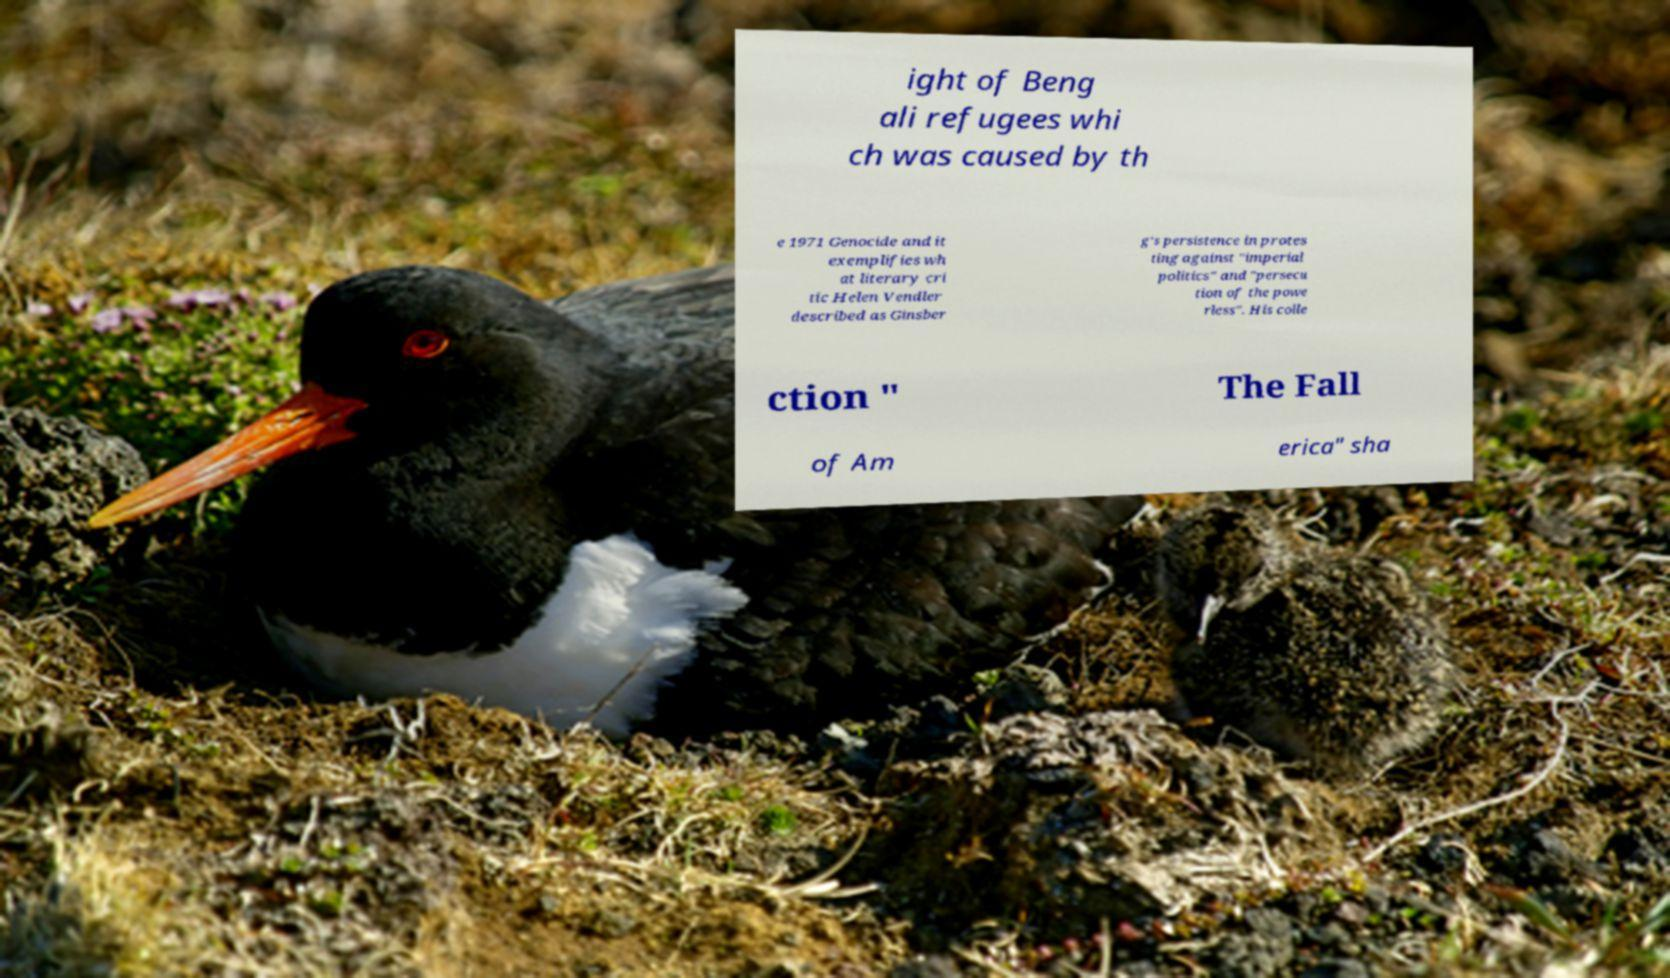Can you read and provide the text displayed in the image?This photo seems to have some interesting text. Can you extract and type it out for me? ight of Beng ali refugees whi ch was caused by th e 1971 Genocide and it exemplifies wh at literary cri tic Helen Vendler described as Ginsber g's persistence in protes ting against "imperial politics" and "persecu tion of the powe rless". His colle ction " The Fall of Am erica" sha 